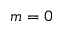Convert formula to latex. <formula><loc_0><loc_0><loc_500><loc_500>m = 0</formula> 